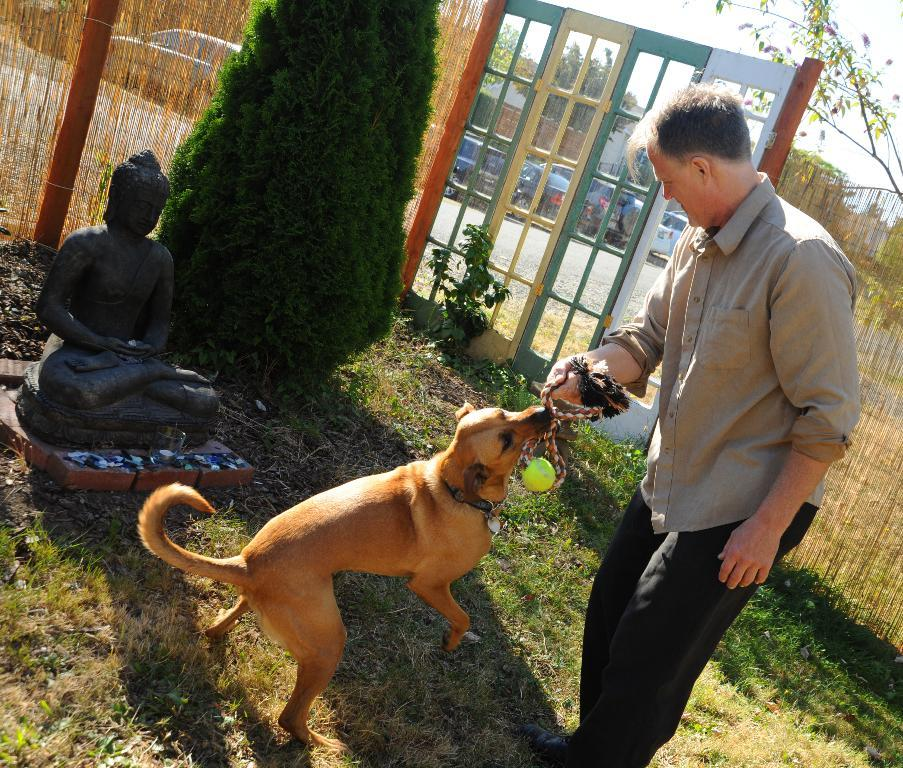Who is present in the image? There is a man in the image. What other living creature is in the image? There is a dog in the image. Where are the man and dog located? The man and dog are on the ground in the image. What can be seen in the background of the image? There is a tree in the image. What is visible in the distance? There are vehicles on the road in the image. How does the man's sock help prevent an earthquake in the image? There is no mention of a sock or an earthquake in the image, so it is not possible to answer that question. 